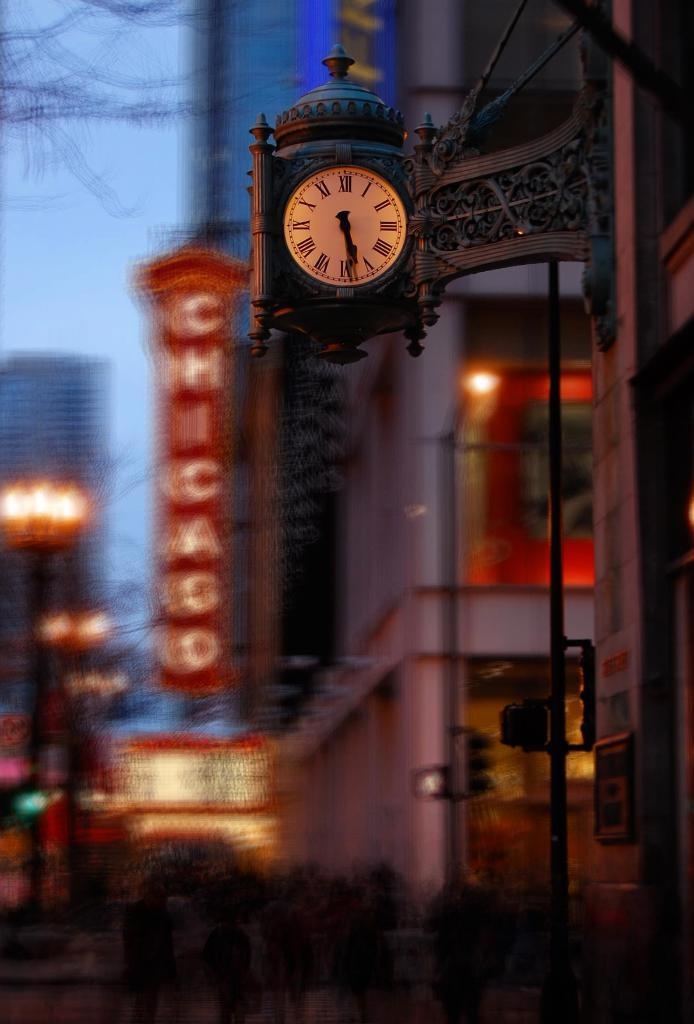What object is present in the image that displays time? There is a clock in the image. Where is the clock located in the image? The clock is attached to a wall. What can be seen in the background of the image? There are buildings and poles in the background of the image. What is visible at the top of the image? The sky is visible at the top of the image. How far away is the worm from the watch in the image? There is no worm or watch present in the image. 